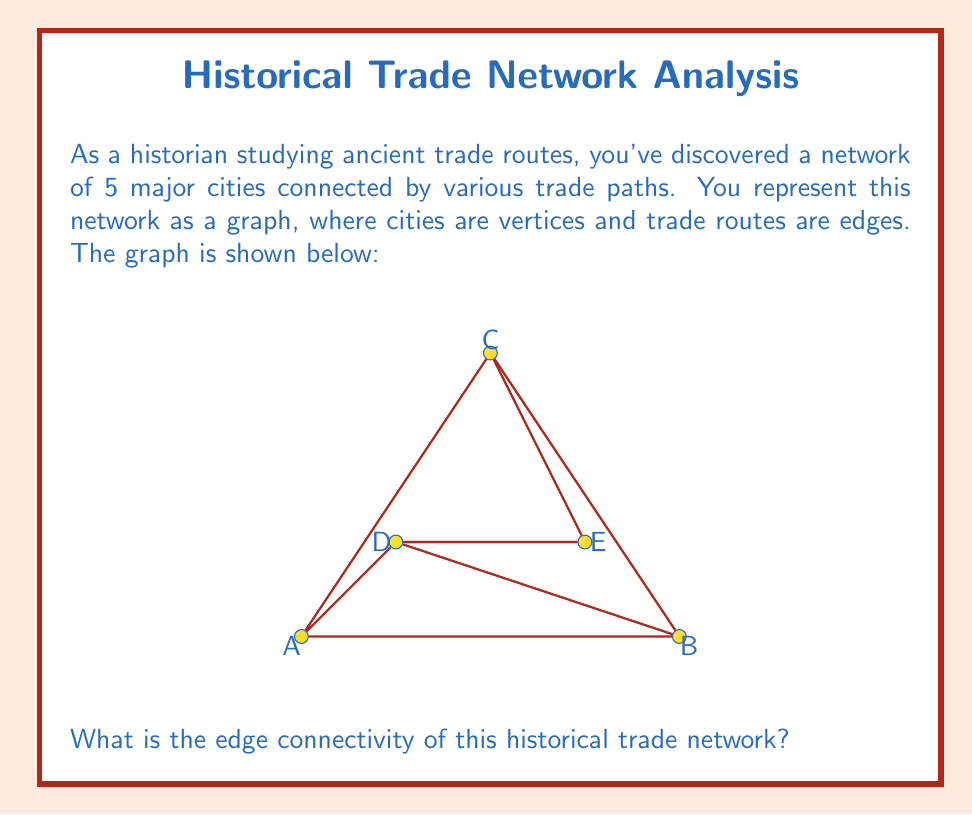Show me your answer to this math problem. To solve this problem, we need to understand the concept of edge connectivity in graph theory and how it applies to our historical trade network. Let's break it down step-by-step:

1) Edge connectivity is defined as the minimum number of edges that need to be removed to disconnect the graph.

2) In our graph, we have 5 vertices (cities) and 7 edges (trade routes).

3) To find the edge connectivity, we need to identify the minimum cut set - the smallest set of edges whose removal would disconnect the graph.

4) Let's analyze potential cut sets:
   - Removing edges AD and BD would disconnect vertex D from the rest of the graph.
   - Removing edges AE and BE would disconnect vertex E from the rest of the graph.
   - Removing edges AC, BC, and CE would disconnect vertex C from the rest of the graph.

5) The smallest of these cut sets contains 2 edges.

6) We can verify that removing any single edge would not disconnect the graph, as there are alternative paths between all pairs of vertices.

7) Therefore, the edge connectivity of this graph is 2.

In the context of our historical trade network, this means that at least two trade routes would need to be disrupted to completely isolate any city from the network.
Answer: 2 